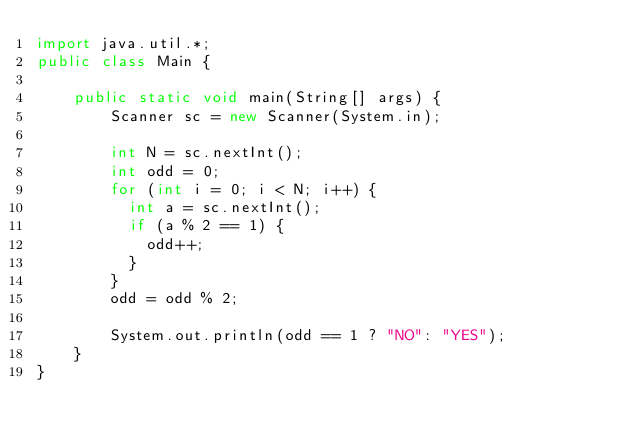<code> <loc_0><loc_0><loc_500><loc_500><_Java_>import java.util.*;
public class Main {
	
    public static void main(String[] args) {
        Scanner sc = new Scanner(System.in);
        
        int N = sc.nextInt();
        int odd = 0;
        for (int i = 0; i < N; i++) {
        	int a = sc.nextInt();
        	if (a % 2 == 1) {
        		odd++;
        	}
        }
        odd = odd % 2;
        
        System.out.println(odd == 1 ? "NO": "YES");
    }
}</code> 